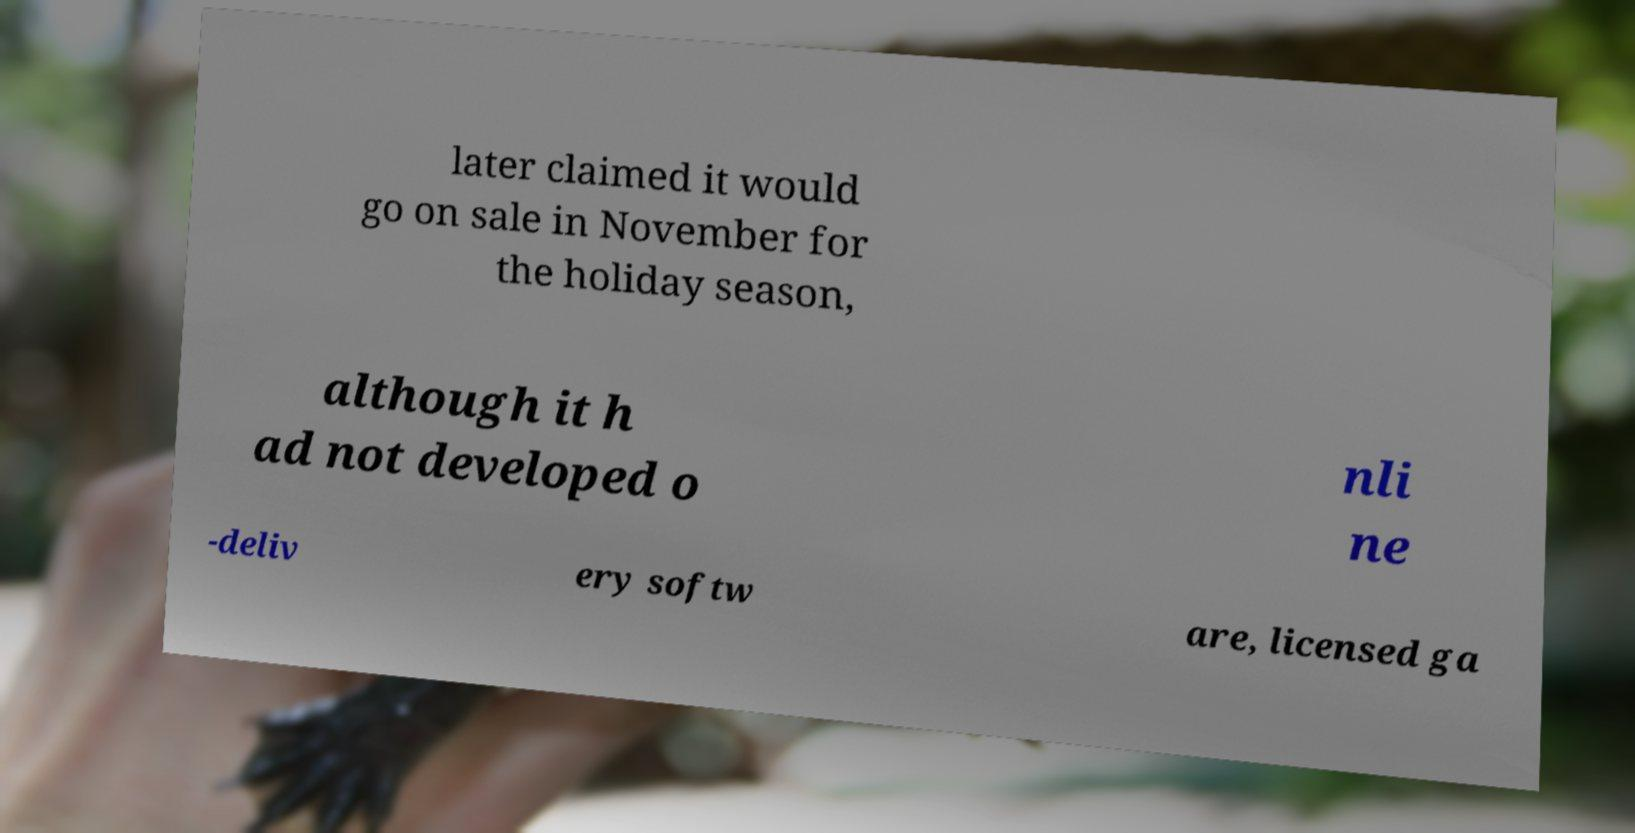I need the written content from this picture converted into text. Can you do that? later claimed it would go on sale in November for the holiday season, although it h ad not developed o nli ne -deliv ery softw are, licensed ga 